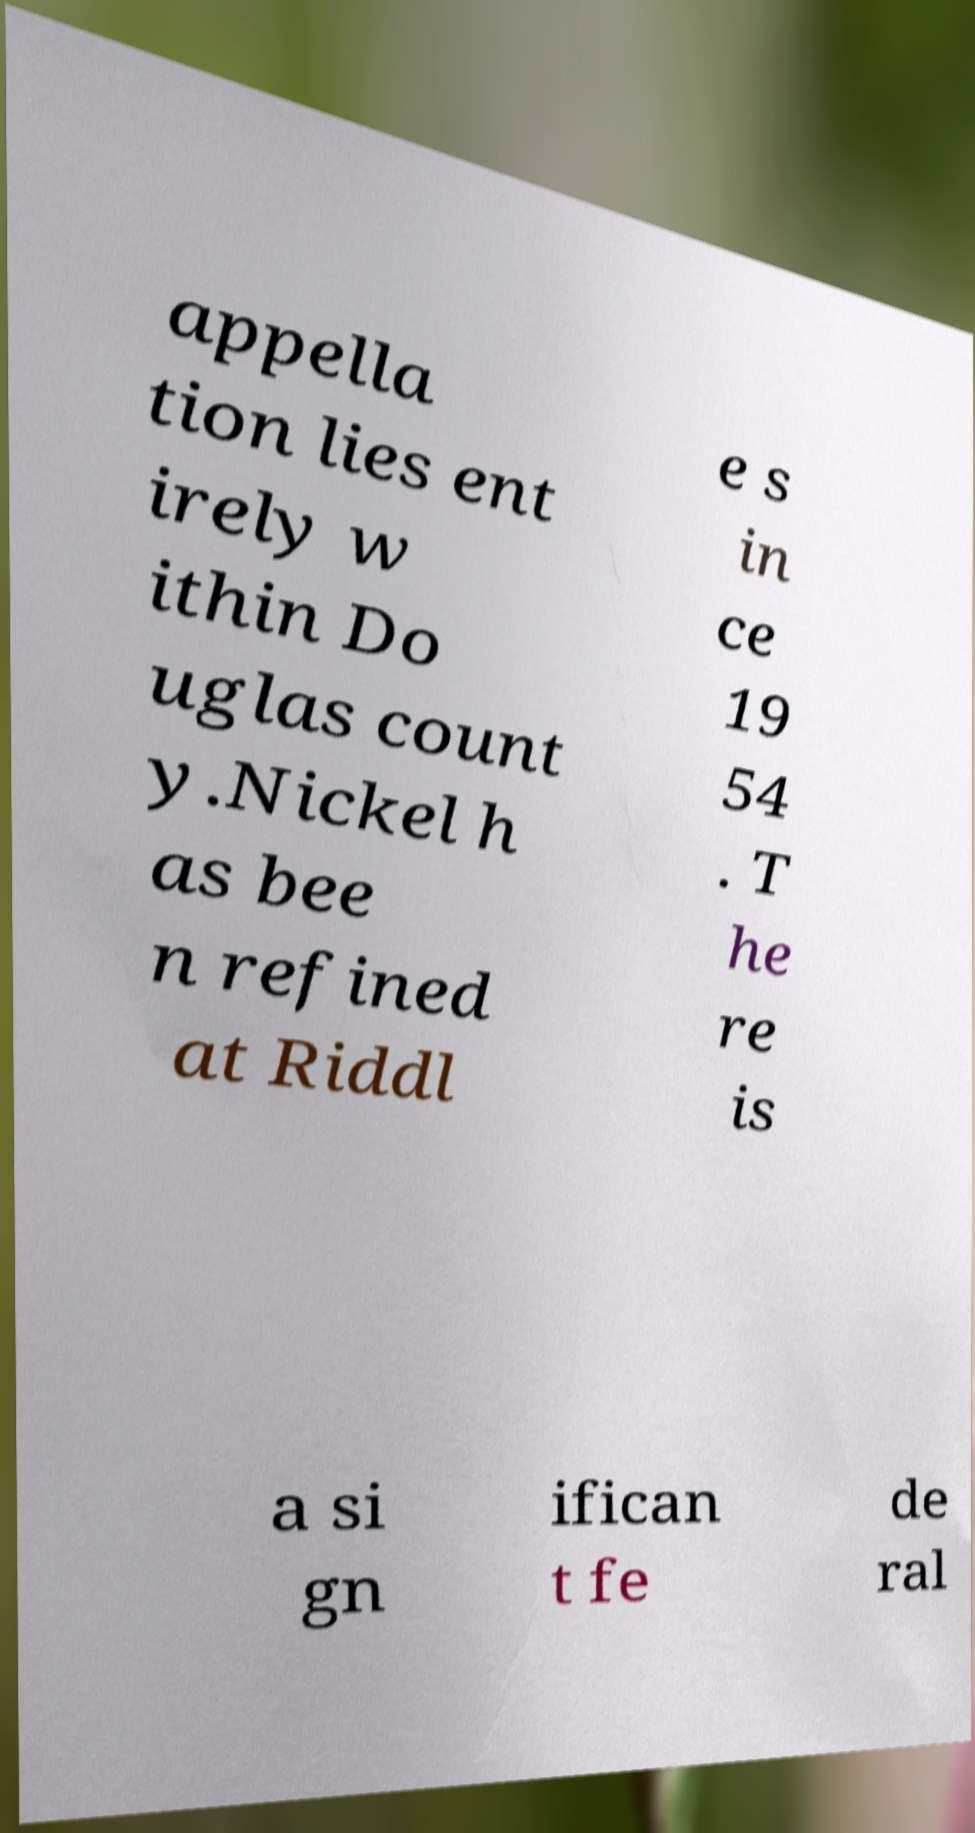I need the written content from this picture converted into text. Can you do that? appella tion lies ent irely w ithin Do uglas count y.Nickel h as bee n refined at Riddl e s in ce 19 54 . T he re is a si gn ifican t fe de ral 